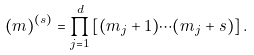Convert formula to latex. <formula><loc_0><loc_0><loc_500><loc_500>( m ) ^ { ( s ) } = \prod _ { j = 1 } ^ { d } \left [ ( m _ { j } + 1 ) \cdots ( m _ { j } + s ) \right ] .</formula> 